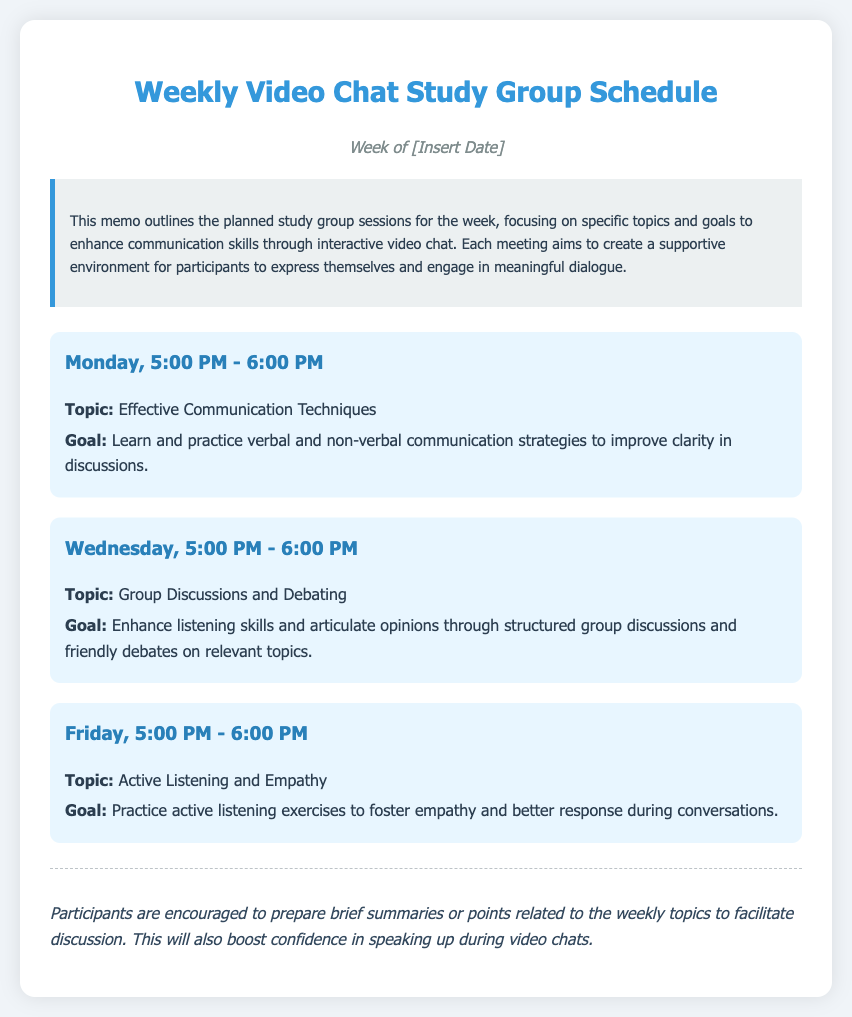What day and time is the first session scheduled? The first session is listed under Monday at 5:00 PM to 6:00 PM.
Answer: Monday, 5:00 PM - 6:00 PM What is the topic for the session on Wednesday? The topic for Wednesday's session is clearly stated as "Group Discussions and Debating."
Answer: Group Discussions and Debating What is the goal of the session on Friday? The goal of the Friday session is outlined as practicing active listening exercises to foster empathy and better response during conversations.
Answer: Practice active listening exercises How many sessions are scheduled for the week? The document lists a total of three sessions for the week.
Answer: Three What is encouraged from participants before the discussions? The memo emphasizes that participants should prepare brief summaries or points related to weekly topics.
Answer: Prepare brief summaries What color is the background of the document? The background color of the document is specified as a light color in the style description, which is a very light grayish color.
Answer: Light grayish color What is the primary focus of the study group sessions? The memo states that the primary focus is to enhance communication skills through interactive video chat.
Answer: Enhance communication skills 